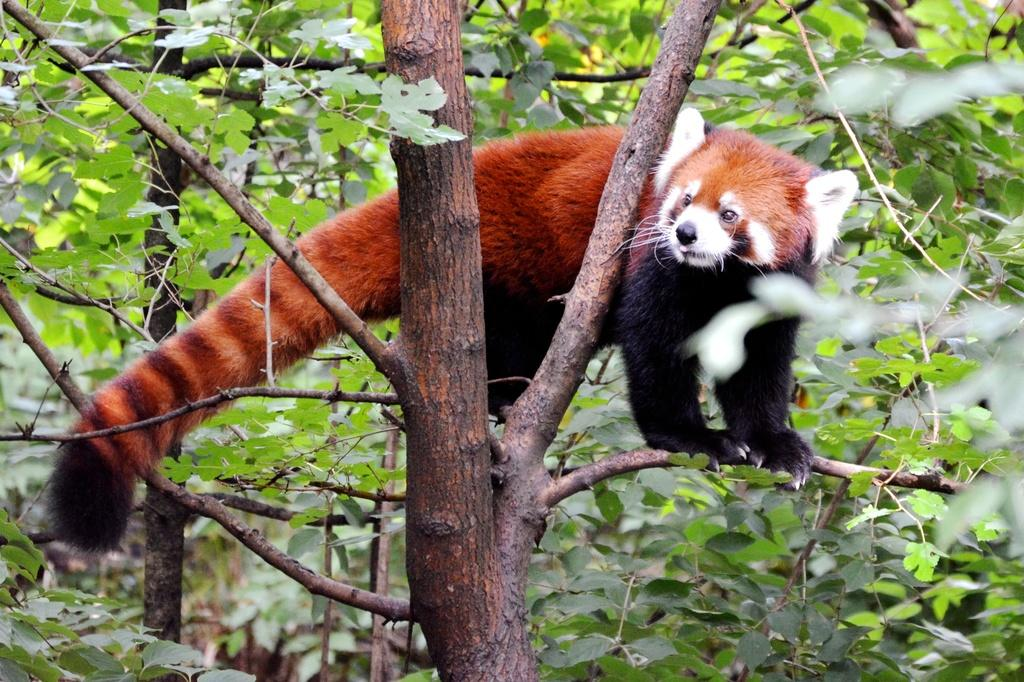What type of living creature is in the image? There is an animal in the image. Where is the animal located? The animal is on a tree. What type of bed can be seen in the image? There is no bed present in the image; it features an animal on a tree. What type of office equipment can be seen in the image? There is no office equipment present in the image; it features an animal on a tree. 